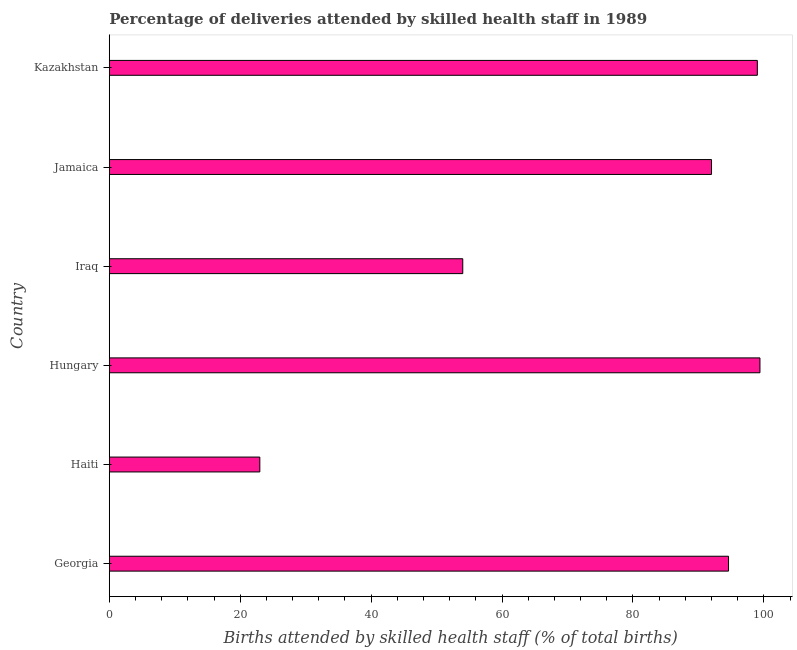Does the graph contain any zero values?
Provide a succinct answer. No. Does the graph contain grids?
Keep it short and to the point. No. What is the title of the graph?
Provide a succinct answer. Percentage of deliveries attended by skilled health staff in 1989. What is the label or title of the X-axis?
Keep it short and to the point. Births attended by skilled health staff (% of total births). What is the number of births attended by skilled health staff in Iraq?
Your response must be concise. 54. Across all countries, what is the maximum number of births attended by skilled health staff?
Your answer should be compact. 99.4. In which country was the number of births attended by skilled health staff maximum?
Offer a terse response. Hungary. In which country was the number of births attended by skilled health staff minimum?
Your response must be concise. Haiti. What is the sum of the number of births attended by skilled health staff?
Keep it short and to the point. 462. What is the difference between the number of births attended by skilled health staff in Hungary and Iraq?
Give a very brief answer. 45.4. What is the median number of births attended by skilled health staff?
Provide a short and direct response. 93.3. What is the ratio of the number of births attended by skilled health staff in Georgia to that in Iraq?
Your answer should be very brief. 1.75. Is the difference between the number of births attended by skilled health staff in Haiti and Hungary greater than the difference between any two countries?
Offer a terse response. Yes. Is the sum of the number of births attended by skilled health staff in Georgia and Iraq greater than the maximum number of births attended by skilled health staff across all countries?
Ensure brevity in your answer.  Yes. What is the difference between the highest and the lowest number of births attended by skilled health staff?
Your answer should be compact. 76.4. Are all the bars in the graph horizontal?
Ensure brevity in your answer.  Yes. How many countries are there in the graph?
Keep it short and to the point. 6. Are the values on the major ticks of X-axis written in scientific E-notation?
Ensure brevity in your answer.  No. What is the Births attended by skilled health staff (% of total births) in Georgia?
Your answer should be very brief. 94.6. What is the Births attended by skilled health staff (% of total births) of Hungary?
Your response must be concise. 99.4. What is the Births attended by skilled health staff (% of total births) of Jamaica?
Offer a very short reply. 92. What is the Births attended by skilled health staff (% of total births) of Kazakhstan?
Offer a terse response. 99. What is the difference between the Births attended by skilled health staff (% of total births) in Georgia and Haiti?
Make the answer very short. 71.6. What is the difference between the Births attended by skilled health staff (% of total births) in Georgia and Hungary?
Your answer should be very brief. -4.8. What is the difference between the Births attended by skilled health staff (% of total births) in Georgia and Iraq?
Provide a short and direct response. 40.6. What is the difference between the Births attended by skilled health staff (% of total births) in Georgia and Kazakhstan?
Keep it short and to the point. -4.4. What is the difference between the Births attended by skilled health staff (% of total births) in Haiti and Hungary?
Keep it short and to the point. -76.4. What is the difference between the Births attended by skilled health staff (% of total births) in Haiti and Iraq?
Keep it short and to the point. -31. What is the difference between the Births attended by skilled health staff (% of total births) in Haiti and Jamaica?
Ensure brevity in your answer.  -69. What is the difference between the Births attended by skilled health staff (% of total births) in Haiti and Kazakhstan?
Make the answer very short. -76. What is the difference between the Births attended by skilled health staff (% of total births) in Hungary and Iraq?
Your answer should be compact. 45.4. What is the difference between the Births attended by skilled health staff (% of total births) in Hungary and Jamaica?
Give a very brief answer. 7.4. What is the difference between the Births attended by skilled health staff (% of total births) in Hungary and Kazakhstan?
Your answer should be very brief. 0.4. What is the difference between the Births attended by skilled health staff (% of total births) in Iraq and Jamaica?
Your answer should be very brief. -38. What is the difference between the Births attended by skilled health staff (% of total births) in Iraq and Kazakhstan?
Offer a very short reply. -45. What is the ratio of the Births attended by skilled health staff (% of total births) in Georgia to that in Haiti?
Give a very brief answer. 4.11. What is the ratio of the Births attended by skilled health staff (% of total births) in Georgia to that in Hungary?
Make the answer very short. 0.95. What is the ratio of the Births attended by skilled health staff (% of total births) in Georgia to that in Iraq?
Your answer should be very brief. 1.75. What is the ratio of the Births attended by skilled health staff (% of total births) in Georgia to that in Jamaica?
Ensure brevity in your answer.  1.03. What is the ratio of the Births attended by skilled health staff (% of total births) in Georgia to that in Kazakhstan?
Your answer should be compact. 0.96. What is the ratio of the Births attended by skilled health staff (% of total births) in Haiti to that in Hungary?
Your answer should be very brief. 0.23. What is the ratio of the Births attended by skilled health staff (% of total births) in Haiti to that in Iraq?
Your answer should be compact. 0.43. What is the ratio of the Births attended by skilled health staff (% of total births) in Haiti to that in Kazakhstan?
Make the answer very short. 0.23. What is the ratio of the Births attended by skilled health staff (% of total births) in Hungary to that in Iraq?
Provide a succinct answer. 1.84. What is the ratio of the Births attended by skilled health staff (% of total births) in Hungary to that in Jamaica?
Provide a succinct answer. 1.08. What is the ratio of the Births attended by skilled health staff (% of total births) in Iraq to that in Jamaica?
Your answer should be very brief. 0.59. What is the ratio of the Births attended by skilled health staff (% of total births) in Iraq to that in Kazakhstan?
Provide a succinct answer. 0.55. What is the ratio of the Births attended by skilled health staff (% of total births) in Jamaica to that in Kazakhstan?
Give a very brief answer. 0.93. 